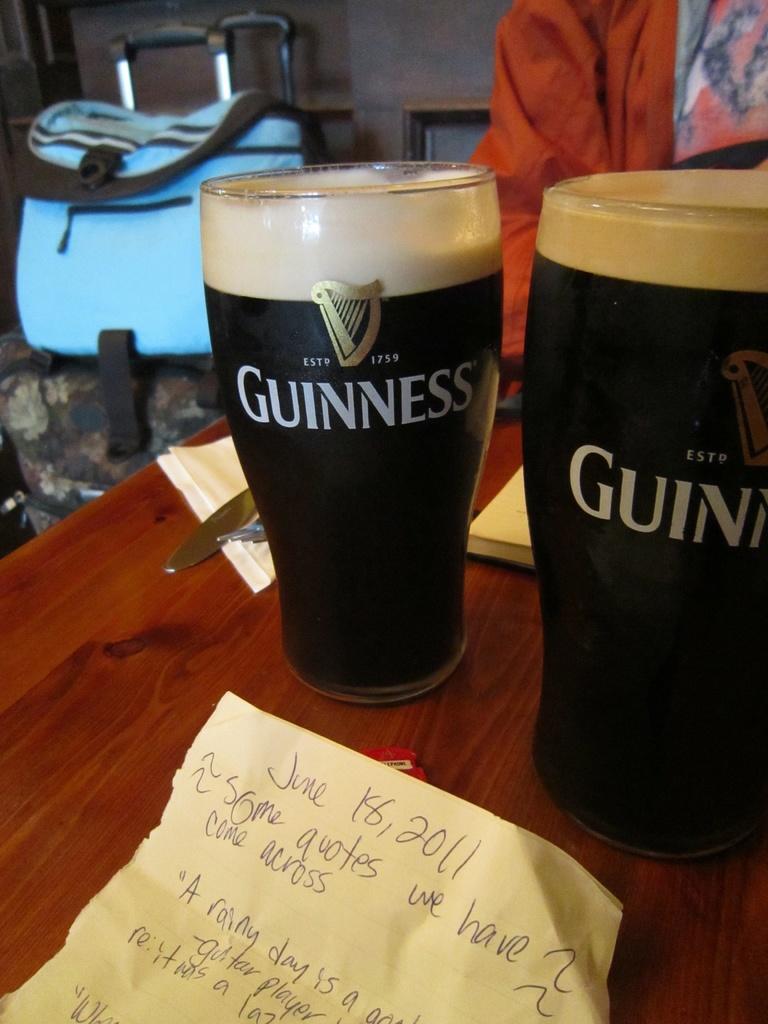Can you describe this image briefly? In this picture I can see two glasses, papers and other objects on a wooden surface. In the background, I can see a person and a bag. 